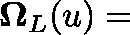Convert formula to latex. <formula><loc_0><loc_0><loc_500><loc_500>\Omega _ { L } ( \mathfrak { u } ) =</formula> 